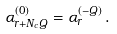Convert formula to latex. <formula><loc_0><loc_0><loc_500><loc_500>\alpha _ { r + N _ { c } Q } ^ { ( 0 ) } = \alpha _ { r } ^ { ( - Q ) } \, .</formula> 